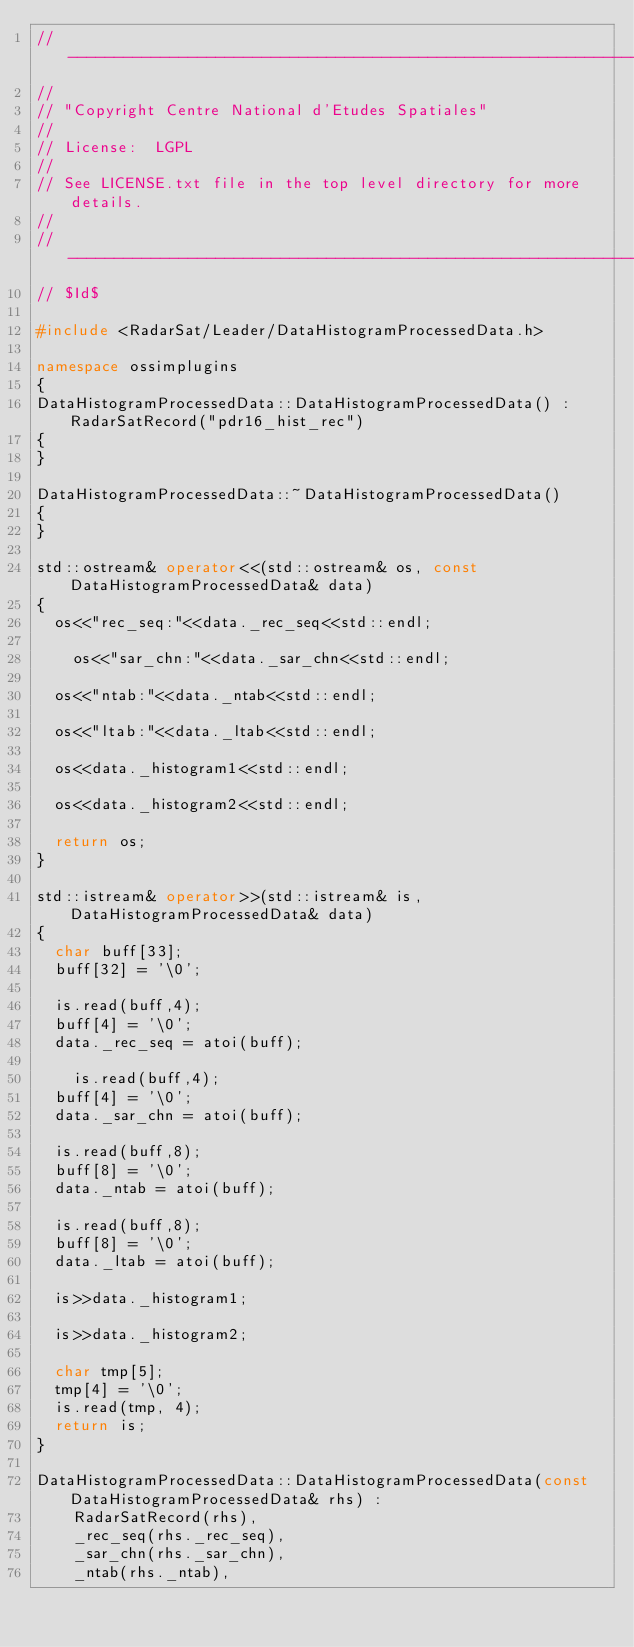Convert code to text. <code><loc_0><loc_0><loc_500><loc_500><_C++_>//----------------------------------------------------------------------------
//
// "Copyright Centre National d'Etudes Spatiales"
//
// License:  LGPL
//
// See LICENSE.txt file in the top level directory for more details.
//
//----------------------------------------------------------------------------
// $Id$

#include <RadarSat/Leader/DataHistogramProcessedData.h>

namespace ossimplugins
{
DataHistogramProcessedData::DataHistogramProcessedData() : RadarSatRecord("pdr16_hist_rec")
{
}

DataHistogramProcessedData::~DataHistogramProcessedData()
{
}

std::ostream& operator<<(std::ostream& os, const DataHistogramProcessedData& data)
{
	os<<"rec_seq:"<<data._rec_seq<<std::endl;

    os<<"sar_chn:"<<data._sar_chn<<std::endl;

	os<<"ntab:"<<data._ntab<<std::endl;

	os<<"ltab:"<<data._ltab<<std::endl;

	os<<data._histogram1<<std::endl;

	os<<data._histogram2<<std::endl;

	return os;
}

std::istream& operator>>(std::istream& is, DataHistogramProcessedData& data)
{
	char buff[33];
	buff[32] = '\0';

	is.read(buff,4);
	buff[4] = '\0';
	data._rec_seq = atoi(buff);

    is.read(buff,4);
	buff[4] = '\0';
	data._sar_chn = atoi(buff);

	is.read(buff,8);
	buff[8] = '\0';
	data._ntab = atoi(buff);

	is.read(buff,8);
	buff[8] = '\0';
	data._ltab = atoi(buff);

	is>>data._histogram1;

	is>>data._histogram2;

	char tmp[5];
	tmp[4] = '\0';
	is.read(tmp, 4);
	return is;
}

DataHistogramProcessedData::DataHistogramProcessedData(const DataHistogramProcessedData& rhs) :
		RadarSatRecord(rhs),
		_rec_seq(rhs._rec_seq),
		_sar_chn(rhs._sar_chn),
		_ntab(rhs._ntab),</code> 